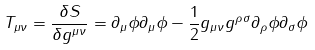Convert formula to latex. <formula><loc_0><loc_0><loc_500><loc_500>T _ { \mu \nu } = \frac { \delta S } { \delta g ^ { \mu \nu } } = \partial _ { \mu } \phi \partial _ { \mu } \phi - \frac { 1 } { 2 } g _ { \mu \nu } g ^ { \rho \sigma } \partial _ { \rho } \phi \partial _ { \sigma } \phi</formula> 